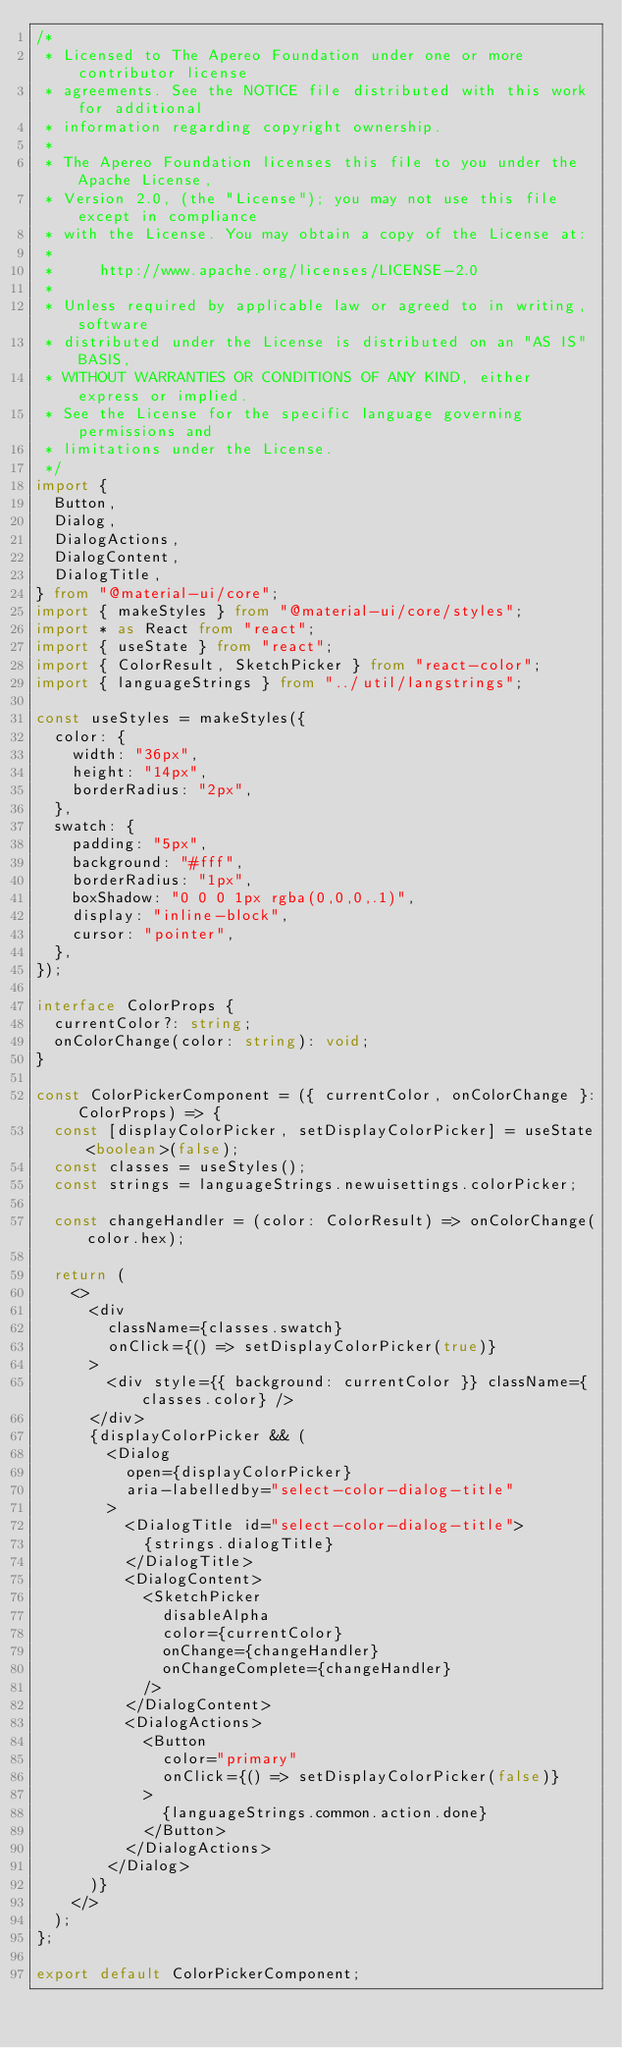Convert code to text. <code><loc_0><loc_0><loc_500><loc_500><_TypeScript_>/*
 * Licensed to The Apereo Foundation under one or more contributor license
 * agreements. See the NOTICE file distributed with this work for additional
 * information regarding copyright ownership.
 *
 * The Apereo Foundation licenses this file to you under the Apache License,
 * Version 2.0, (the "License"); you may not use this file except in compliance
 * with the License. You may obtain a copy of the License at:
 *
 *     http://www.apache.org/licenses/LICENSE-2.0
 *
 * Unless required by applicable law or agreed to in writing, software
 * distributed under the License is distributed on an "AS IS" BASIS,
 * WITHOUT WARRANTIES OR CONDITIONS OF ANY KIND, either express or implied.
 * See the License for the specific language governing permissions and
 * limitations under the License.
 */
import {
  Button,
  Dialog,
  DialogActions,
  DialogContent,
  DialogTitle,
} from "@material-ui/core";
import { makeStyles } from "@material-ui/core/styles";
import * as React from "react";
import { useState } from "react";
import { ColorResult, SketchPicker } from "react-color";
import { languageStrings } from "../util/langstrings";

const useStyles = makeStyles({
  color: {
    width: "36px",
    height: "14px",
    borderRadius: "2px",
  },
  swatch: {
    padding: "5px",
    background: "#fff",
    borderRadius: "1px",
    boxShadow: "0 0 0 1px rgba(0,0,0,.1)",
    display: "inline-block",
    cursor: "pointer",
  },
});

interface ColorProps {
  currentColor?: string;
  onColorChange(color: string): void;
}

const ColorPickerComponent = ({ currentColor, onColorChange }: ColorProps) => {
  const [displayColorPicker, setDisplayColorPicker] = useState<boolean>(false);
  const classes = useStyles();
  const strings = languageStrings.newuisettings.colorPicker;

  const changeHandler = (color: ColorResult) => onColorChange(color.hex);

  return (
    <>
      <div
        className={classes.swatch}
        onClick={() => setDisplayColorPicker(true)}
      >
        <div style={{ background: currentColor }} className={classes.color} />
      </div>
      {displayColorPicker && (
        <Dialog
          open={displayColorPicker}
          aria-labelledby="select-color-dialog-title"
        >
          <DialogTitle id="select-color-dialog-title">
            {strings.dialogTitle}
          </DialogTitle>
          <DialogContent>
            <SketchPicker
              disableAlpha
              color={currentColor}
              onChange={changeHandler}
              onChangeComplete={changeHandler}
            />
          </DialogContent>
          <DialogActions>
            <Button
              color="primary"
              onClick={() => setDisplayColorPicker(false)}
            >
              {languageStrings.common.action.done}
            </Button>
          </DialogActions>
        </Dialog>
      )}
    </>
  );
};

export default ColorPickerComponent;
</code> 